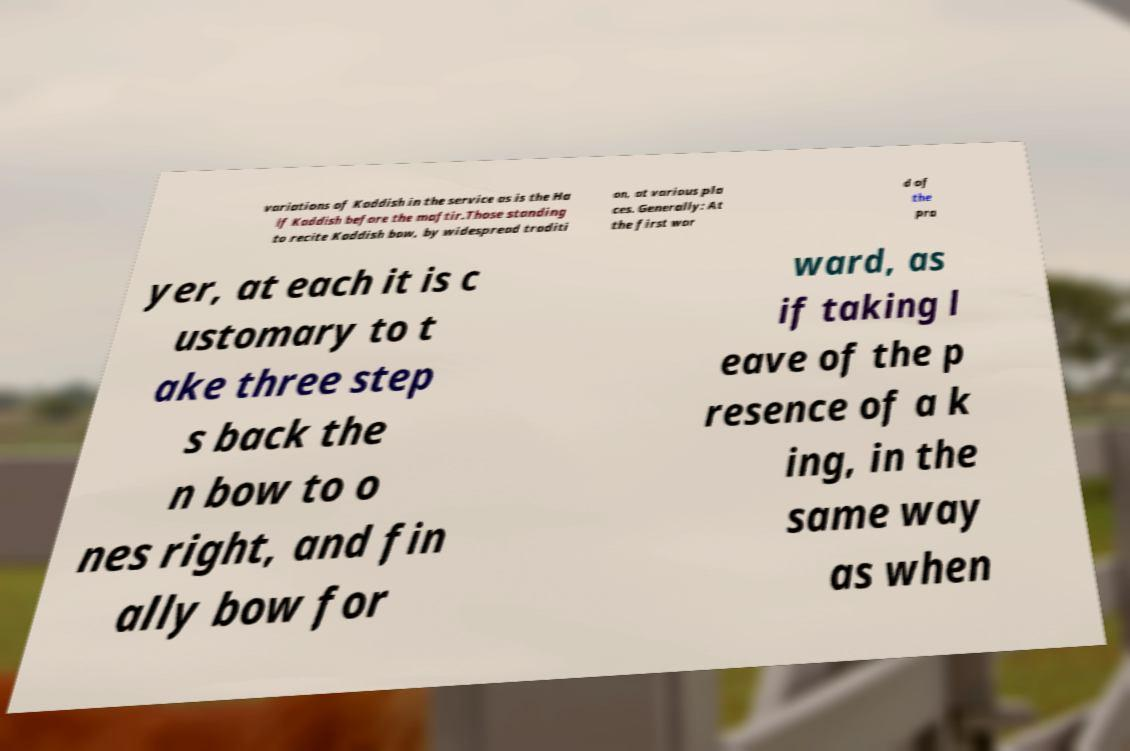There's text embedded in this image that I need extracted. Can you transcribe it verbatim? variations of Kaddish in the service as is the Ha lf Kaddish before the maftir.Those standing to recite Kaddish bow, by widespread traditi on, at various pla ces. Generally: At the first wor d of the pra yer, at each it is c ustomary to t ake three step s back the n bow to o nes right, and fin ally bow for ward, as if taking l eave of the p resence of a k ing, in the same way as when 